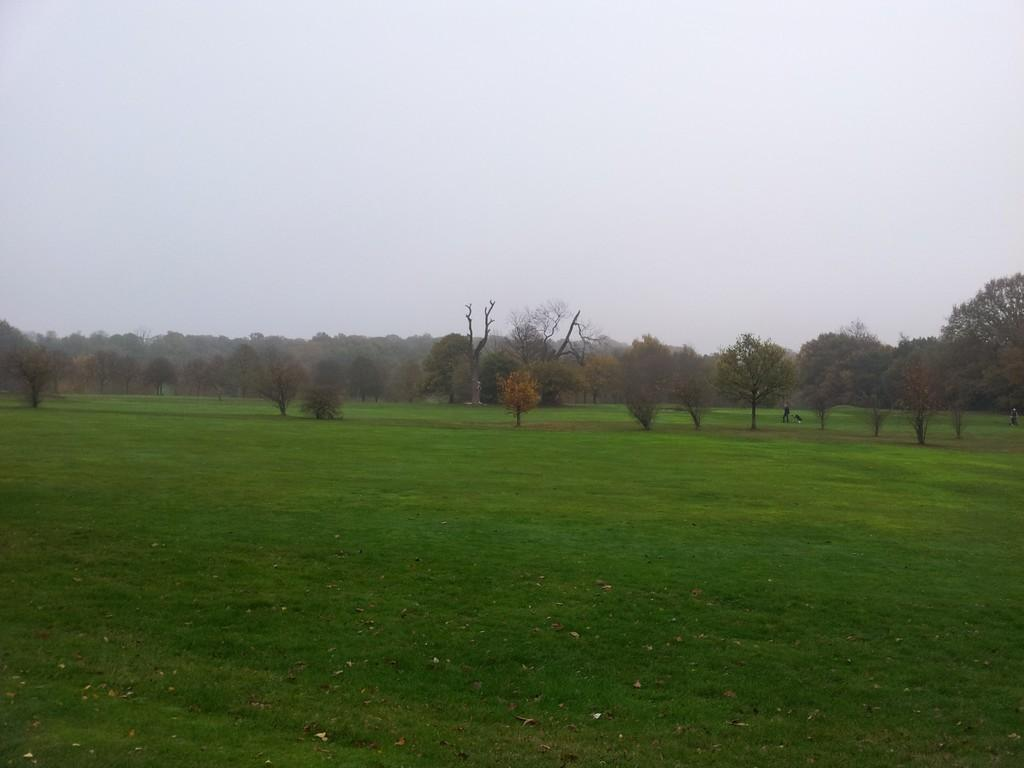What type of terrain is visible in the image? There is grassy land in the image. Are there any plants or vegetation in the image? Yes, there are trees in the image. What color is the sky in the image? The sky is white in color. Where is the playground located in the image? There is no playground present in the image. What type of clover can be seen growing in the grassy land? There is no clover visible in the image; only grassy land and trees are present. 